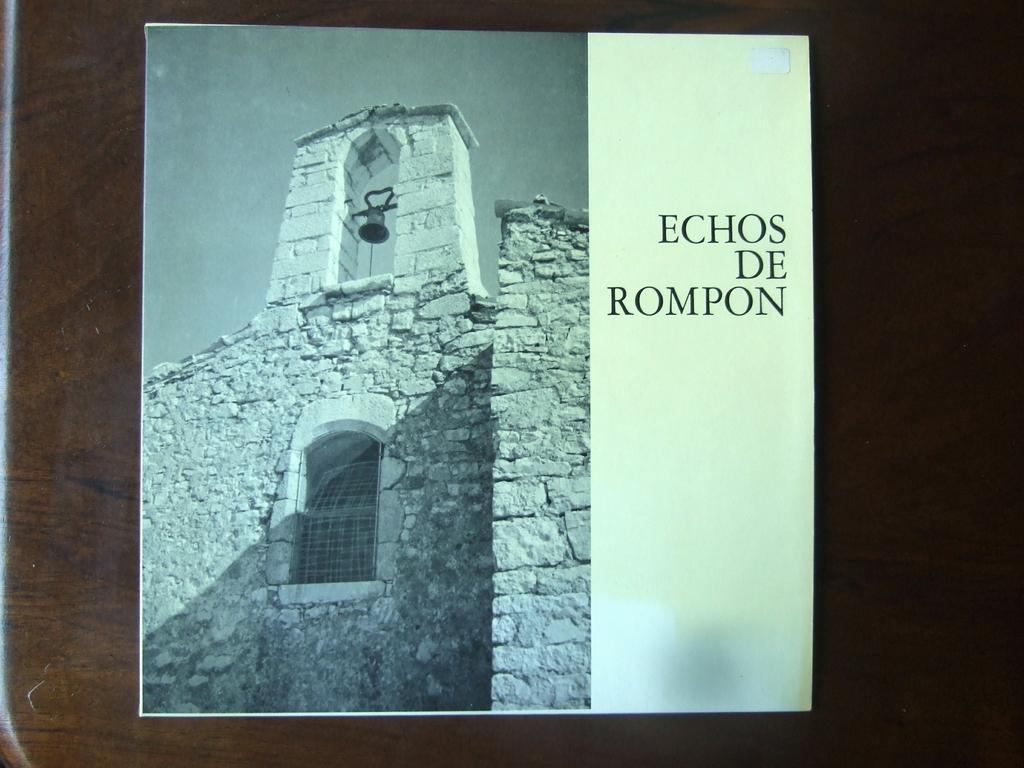<image>
Present a compact description of the photo's key features. A picture of a bell tower in black and white with the text "echos de Rompon" on the right. 